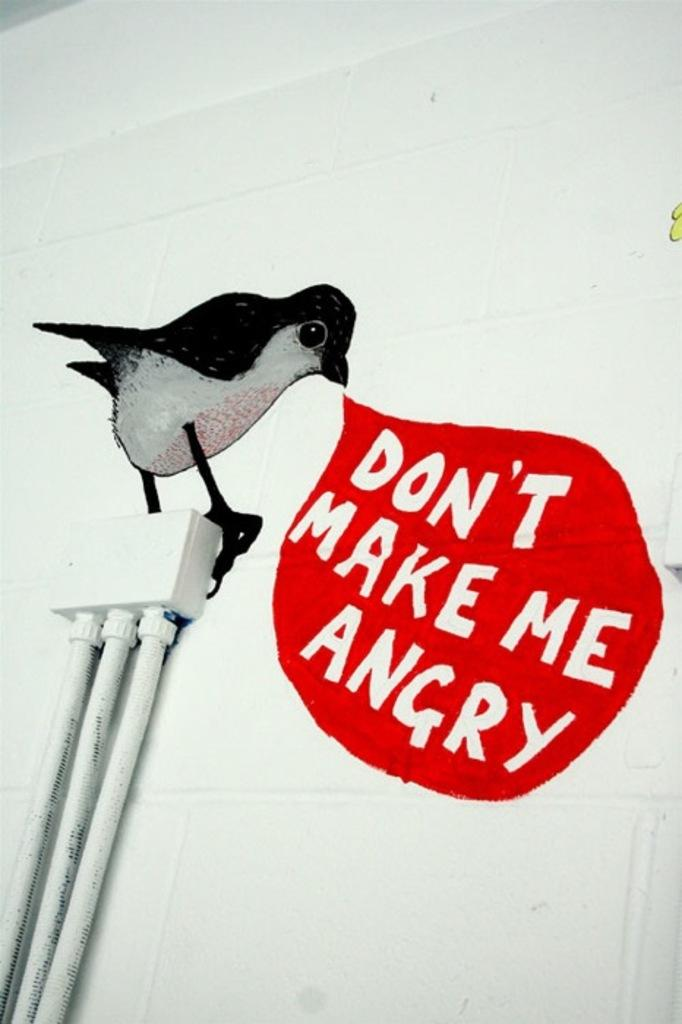What is on the wall in the image? There is a painting of a bird, writing, pipes, and a box on the wall in the image. Can you describe the painting on the wall? The painting on the wall is of a bird. What else can be found on the wall besides the painting? There is writing and pipes on the wall, as well as a box. How does the lawyer attack the sugar in the image? There is no lawyer, sugar, or attack depicted in the image. 